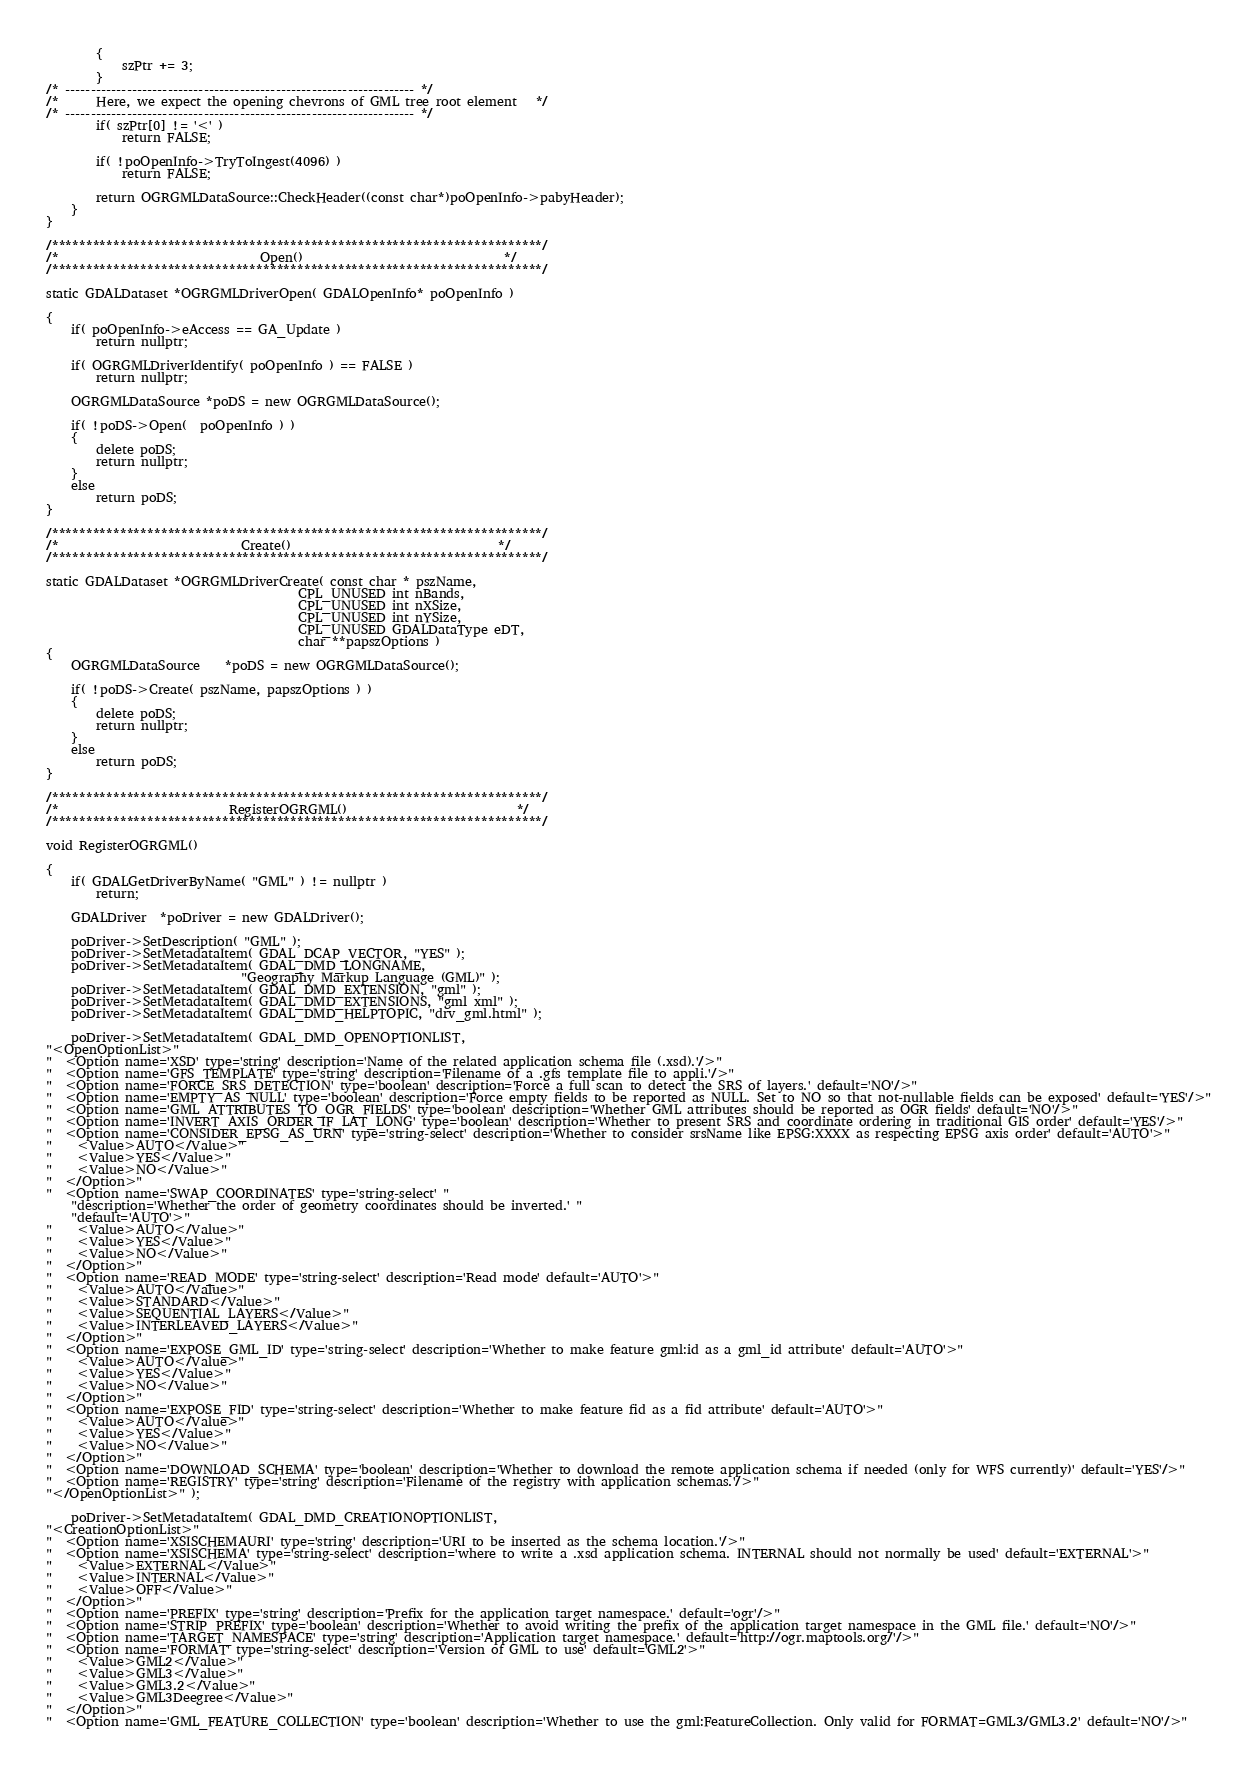<code> <loc_0><loc_0><loc_500><loc_500><_C++_>        {
            szPtr += 3;
        }
/* -------------------------------------------------------------------- */
/*      Here, we expect the opening chevrons of GML tree root element   */
/* -------------------------------------------------------------------- */
        if( szPtr[0] != '<' )
            return FALSE;

        if( !poOpenInfo->TryToIngest(4096) )
            return FALSE;

        return OGRGMLDataSource::CheckHeader((const char*)poOpenInfo->pabyHeader);
    }
}

/************************************************************************/
/*                                Open()                                */
/************************************************************************/

static GDALDataset *OGRGMLDriverOpen( GDALOpenInfo* poOpenInfo )

{
    if( poOpenInfo->eAccess == GA_Update )
        return nullptr;

    if( OGRGMLDriverIdentify( poOpenInfo ) == FALSE )
        return nullptr;

    OGRGMLDataSource *poDS = new OGRGMLDataSource();

    if( !poDS->Open(  poOpenInfo ) )
    {
        delete poDS;
        return nullptr;
    }
    else
        return poDS;
}

/************************************************************************/
/*                             Create()                                 */
/************************************************************************/

static GDALDataset *OGRGMLDriverCreate( const char * pszName,
                                        CPL_UNUSED int nBands,
                                        CPL_UNUSED int nXSize,
                                        CPL_UNUSED int nYSize,
                                        CPL_UNUSED GDALDataType eDT,
                                        char **papszOptions )
{
    OGRGMLDataSource    *poDS = new OGRGMLDataSource();

    if( !poDS->Create( pszName, papszOptions ) )
    {
        delete poDS;
        return nullptr;
    }
    else
        return poDS;
}

/************************************************************************/
/*                           RegisterOGRGML()                           */
/************************************************************************/

void RegisterOGRGML()

{
    if( GDALGetDriverByName( "GML" ) != nullptr )
        return;

    GDALDriver  *poDriver = new GDALDriver();

    poDriver->SetDescription( "GML" );
    poDriver->SetMetadataItem( GDAL_DCAP_VECTOR, "YES" );
    poDriver->SetMetadataItem( GDAL_DMD_LONGNAME,
                               "Geography Markup Language (GML)" );
    poDriver->SetMetadataItem( GDAL_DMD_EXTENSION, "gml" );
    poDriver->SetMetadataItem( GDAL_DMD_EXTENSIONS, "gml xml" );
    poDriver->SetMetadataItem( GDAL_DMD_HELPTOPIC, "drv_gml.html" );

    poDriver->SetMetadataItem( GDAL_DMD_OPENOPTIONLIST,
"<OpenOptionList>"
"  <Option name='XSD' type='string' description='Name of the related application schema file (.xsd).'/>"
"  <Option name='GFS_TEMPLATE' type='string' description='Filename of a .gfs template file to appli.'/>"
"  <Option name='FORCE_SRS_DETECTION' type='boolean' description='Force a full scan to detect the SRS of layers.' default='NO'/>"
"  <Option name='EMPTY_AS_NULL' type='boolean' description='Force empty fields to be reported as NULL. Set to NO so that not-nullable fields can be exposed' default='YES'/>"
"  <Option name='GML_ATTRIBUTES_TO_OGR_FIELDS' type='boolean' description='Whether GML attributes should be reported as OGR fields' default='NO'/>"
"  <Option name='INVERT_AXIS_ORDER_IF_LAT_LONG' type='boolean' description='Whether to present SRS and coordinate ordering in traditional GIS order' default='YES'/>"
"  <Option name='CONSIDER_EPSG_AS_URN' type='string-select' description='Whether to consider srsName like EPSG:XXXX as respecting EPSG axis order' default='AUTO'>"
"    <Value>AUTO</Value>"
"    <Value>YES</Value>"
"    <Value>NO</Value>"
"  </Option>"
"  <Option name='SWAP_COORDINATES' type='string-select' "
    "description='Whether the order of geometry coordinates should be inverted.' "
    "default='AUTO'>"
"    <Value>AUTO</Value>"
"    <Value>YES</Value>"
"    <Value>NO</Value>"
"  </Option>"
"  <Option name='READ_MODE' type='string-select' description='Read mode' default='AUTO'>"
"    <Value>AUTO</Value>"
"    <Value>STANDARD</Value>"
"    <Value>SEQUENTIAL_LAYERS</Value>"
"    <Value>INTERLEAVED_LAYERS</Value>"
"  </Option>"
"  <Option name='EXPOSE_GML_ID' type='string-select' description='Whether to make feature gml:id as a gml_id attribute' default='AUTO'>"
"    <Value>AUTO</Value>"
"    <Value>YES</Value>"
"    <Value>NO</Value>"
"  </Option>"
"  <Option name='EXPOSE_FID' type='string-select' description='Whether to make feature fid as a fid attribute' default='AUTO'>"
"    <Value>AUTO</Value>"
"    <Value>YES</Value>"
"    <Value>NO</Value>"
"  </Option>"
"  <Option name='DOWNLOAD_SCHEMA' type='boolean' description='Whether to download the remote application schema if needed (only for WFS currently)' default='YES'/>"
"  <Option name='REGISTRY' type='string' description='Filename of the registry with application schemas.'/>"
"</OpenOptionList>" );

    poDriver->SetMetadataItem( GDAL_DMD_CREATIONOPTIONLIST,
"<CreationOptionList>"
"  <Option name='XSISCHEMAURI' type='string' description='URI to be inserted as the schema location.'/>"
"  <Option name='XSISCHEMA' type='string-select' description='where to write a .xsd application schema. INTERNAL should not normally be used' default='EXTERNAL'>"
"    <Value>EXTERNAL</Value>"
"    <Value>INTERNAL</Value>"
"    <Value>OFF</Value>"
"  </Option>"
"  <Option name='PREFIX' type='string' description='Prefix for the application target namespace.' default='ogr'/>"
"  <Option name='STRIP_PREFIX' type='boolean' description='Whether to avoid writing the prefix of the application target namespace in the GML file.' default='NO'/>"
"  <Option name='TARGET_NAMESPACE' type='string' description='Application target namespace.' default='http://ogr.maptools.org/'/>"
"  <Option name='FORMAT' type='string-select' description='Version of GML to use' default='GML2'>"
"    <Value>GML2</Value>"
"    <Value>GML3</Value>"
"    <Value>GML3.2</Value>"
"    <Value>GML3Deegree</Value>"
"  </Option>"
"  <Option name='GML_FEATURE_COLLECTION' type='boolean' description='Whether to use the gml:FeatureCollection. Only valid for FORMAT=GML3/GML3.2' default='NO'/>"</code> 